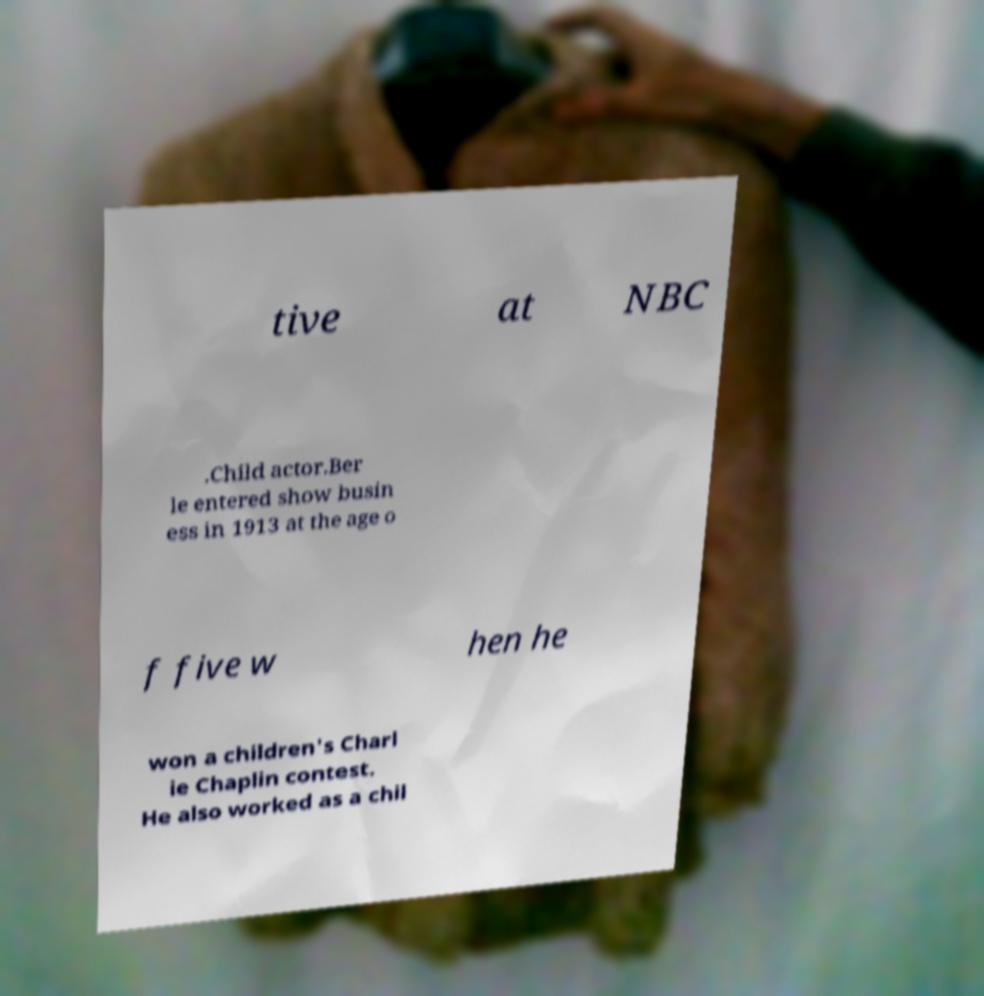Could you assist in decoding the text presented in this image and type it out clearly? tive at NBC .Child actor.Ber le entered show busin ess in 1913 at the age o f five w hen he won a children's Charl ie Chaplin contest. He also worked as a chil 